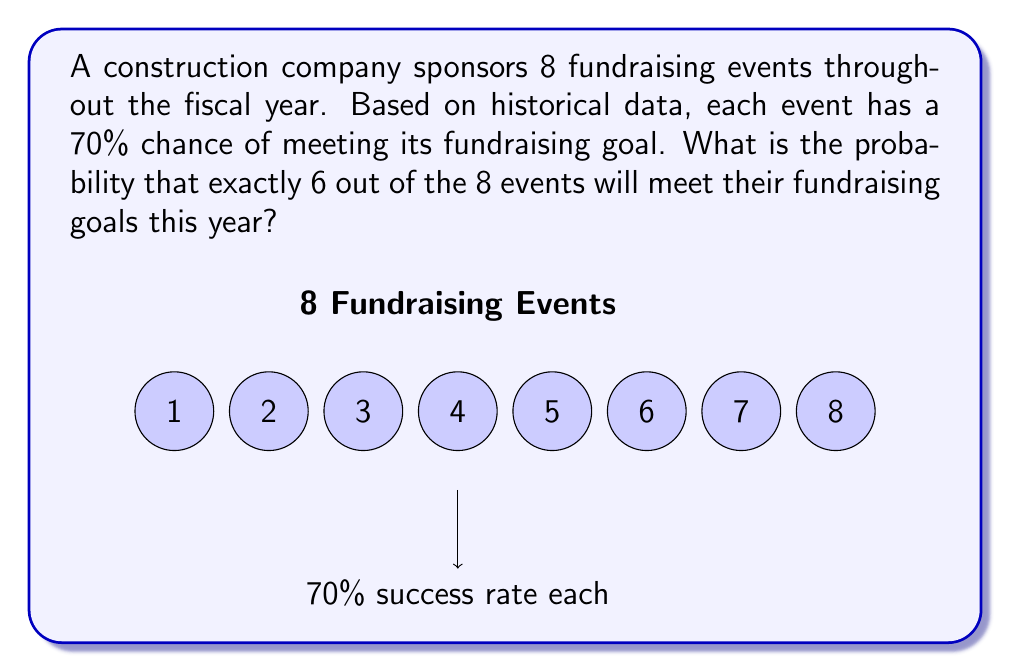Solve this math problem. To solve this problem, we'll use the binomial probability distribution formula:

$$ P(X = k) = \binom{n}{k} p^k (1-p)^{n-k} $$

Where:
- $n$ is the number of trials (events)
- $k$ is the number of successes
- $p$ is the probability of success on each trial

Given:
- $n = 8$ (total number of events)
- $k = 6$ (number of successful events we're interested in)
- $p = 0.70$ (probability of success for each event)

Step 1: Calculate the binomial coefficient $\binom{n}{k}$
$$ \binom{8}{6} = \frac{8!}{6!(8-6)!} = \frac{8!}{6!2!} = 28 $$

Step 2: Calculate $p^k$
$$ 0.70^6 = 0.1176 $$

Step 3: Calculate $(1-p)^{n-k}$
$$ (1-0.70)^{8-6} = 0.30^2 = 0.09 $$

Step 4: Multiply the results from steps 1, 2, and 3
$$ 28 \times 0.1176 \times 0.09 = 0.2962 $$

Therefore, the probability of exactly 6 out of 8 events meeting their fundraising goals is approximately 0.2962 or 29.62%.
Answer: 0.2962 